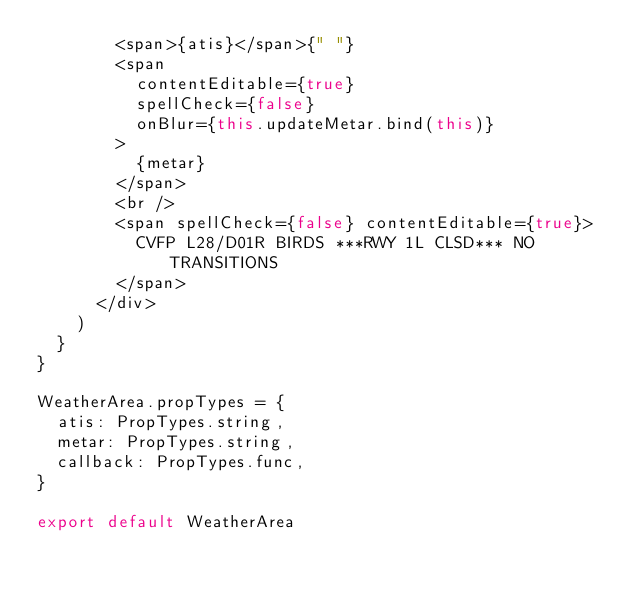Convert code to text. <code><loc_0><loc_0><loc_500><loc_500><_JavaScript_>        <span>{atis}</span>{" "}
        <span
          contentEditable={true}
          spellCheck={false}
          onBlur={this.updateMetar.bind(this)}
        >
          {metar}
        </span>
        <br />
        <span spellCheck={false} contentEditable={true}>
          CVFP L28/D01R BIRDS ***RWY 1L CLSD*** NO TRANSITIONS
        </span>
      </div>
    )
  }
}

WeatherArea.propTypes = {
  atis: PropTypes.string,
  metar: PropTypes.string,
  callback: PropTypes.func,
}

export default WeatherArea
</code> 